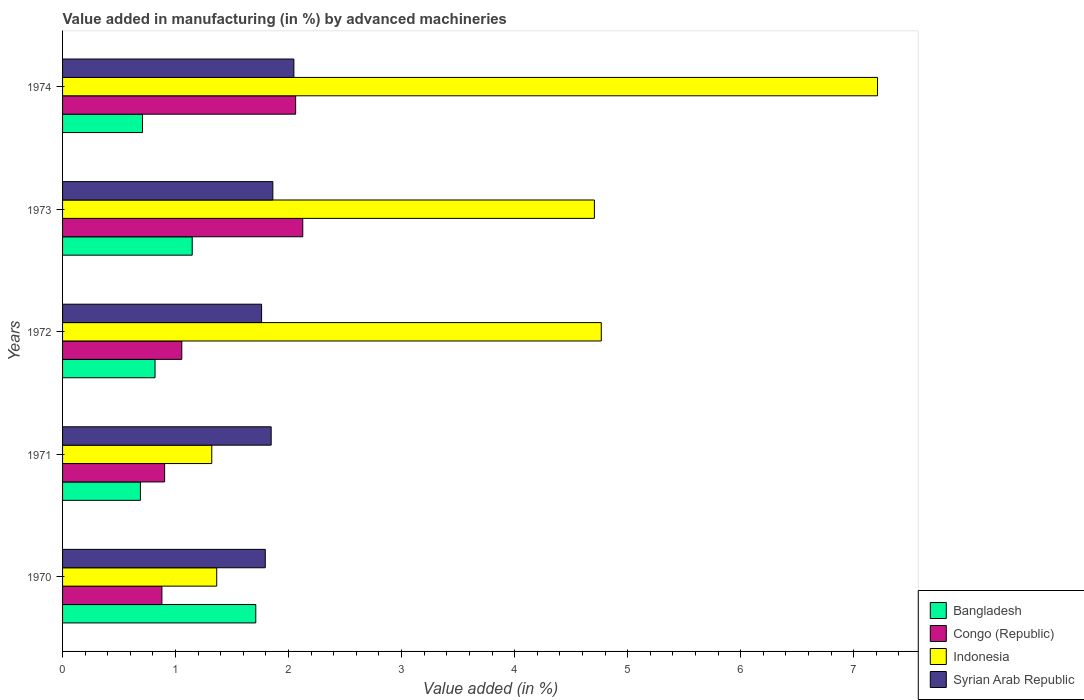How many groups of bars are there?
Give a very brief answer. 5. Are the number of bars on each tick of the Y-axis equal?
Keep it short and to the point. Yes. How many bars are there on the 2nd tick from the top?
Provide a succinct answer. 4. What is the percentage of value added in manufacturing by advanced machineries in Syrian Arab Republic in 1970?
Give a very brief answer. 1.79. Across all years, what is the maximum percentage of value added in manufacturing by advanced machineries in Congo (Republic)?
Provide a succinct answer. 2.13. Across all years, what is the minimum percentage of value added in manufacturing by advanced machineries in Congo (Republic)?
Provide a succinct answer. 0.88. In which year was the percentage of value added in manufacturing by advanced machineries in Indonesia maximum?
Provide a succinct answer. 1974. In which year was the percentage of value added in manufacturing by advanced machineries in Bangladesh minimum?
Provide a succinct answer. 1971. What is the total percentage of value added in manufacturing by advanced machineries in Syrian Arab Republic in the graph?
Give a very brief answer. 9.31. What is the difference between the percentage of value added in manufacturing by advanced machineries in Congo (Republic) in 1971 and that in 1973?
Your answer should be very brief. -1.22. What is the difference between the percentage of value added in manufacturing by advanced machineries in Indonesia in 1970 and the percentage of value added in manufacturing by advanced machineries in Bangladesh in 1973?
Give a very brief answer. 0.22. What is the average percentage of value added in manufacturing by advanced machineries in Indonesia per year?
Provide a short and direct response. 3.87. In the year 1972, what is the difference between the percentage of value added in manufacturing by advanced machineries in Bangladesh and percentage of value added in manufacturing by advanced machineries in Syrian Arab Republic?
Ensure brevity in your answer.  -0.94. What is the ratio of the percentage of value added in manufacturing by advanced machineries in Bangladesh in 1972 to that in 1973?
Provide a short and direct response. 0.71. Is the percentage of value added in manufacturing by advanced machineries in Indonesia in 1972 less than that in 1974?
Offer a terse response. Yes. Is the difference between the percentage of value added in manufacturing by advanced machineries in Bangladesh in 1971 and 1973 greater than the difference between the percentage of value added in manufacturing by advanced machineries in Syrian Arab Republic in 1971 and 1973?
Offer a very short reply. No. What is the difference between the highest and the second highest percentage of value added in manufacturing by advanced machineries in Indonesia?
Provide a short and direct response. 2.44. What is the difference between the highest and the lowest percentage of value added in manufacturing by advanced machineries in Congo (Republic)?
Your answer should be very brief. 1.25. Is the sum of the percentage of value added in manufacturing by advanced machineries in Syrian Arab Republic in 1972 and 1974 greater than the maximum percentage of value added in manufacturing by advanced machineries in Indonesia across all years?
Make the answer very short. No. Is it the case that in every year, the sum of the percentage of value added in manufacturing by advanced machineries in Syrian Arab Republic and percentage of value added in manufacturing by advanced machineries in Congo (Republic) is greater than the sum of percentage of value added in manufacturing by advanced machineries in Bangladesh and percentage of value added in manufacturing by advanced machineries in Indonesia?
Keep it short and to the point. No. What does the 4th bar from the top in 1973 represents?
Offer a very short reply. Bangladesh. What does the 2nd bar from the bottom in 1970 represents?
Your answer should be very brief. Congo (Republic). How many bars are there?
Ensure brevity in your answer.  20. Are all the bars in the graph horizontal?
Provide a succinct answer. Yes. Does the graph contain grids?
Keep it short and to the point. No. How many legend labels are there?
Your answer should be very brief. 4. What is the title of the graph?
Your answer should be compact. Value added in manufacturing (in %) by advanced machineries. What is the label or title of the X-axis?
Ensure brevity in your answer.  Value added (in %). What is the Value added (in %) of Bangladesh in 1970?
Ensure brevity in your answer.  1.71. What is the Value added (in %) of Congo (Republic) in 1970?
Make the answer very short. 0.88. What is the Value added (in %) of Indonesia in 1970?
Give a very brief answer. 1.36. What is the Value added (in %) in Syrian Arab Republic in 1970?
Offer a very short reply. 1.79. What is the Value added (in %) in Bangladesh in 1971?
Your response must be concise. 0.69. What is the Value added (in %) of Congo (Republic) in 1971?
Your answer should be compact. 0.9. What is the Value added (in %) in Indonesia in 1971?
Your response must be concise. 1.32. What is the Value added (in %) of Syrian Arab Republic in 1971?
Provide a succinct answer. 1.85. What is the Value added (in %) of Bangladesh in 1972?
Your answer should be very brief. 0.82. What is the Value added (in %) of Congo (Republic) in 1972?
Give a very brief answer. 1.06. What is the Value added (in %) in Indonesia in 1972?
Offer a terse response. 4.77. What is the Value added (in %) in Syrian Arab Republic in 1972?
Your answer should be compact. 1.76. What is the Value added (in %) in Bangladesh in 1973?
Make the answer very short. 1.15. What is the Value added (in %) of Congo (Republic) in 1973?
Keep it short and to the point. 2.13. What is the Value added (in %) of Indonesia in 1973?
Ensure brevity in your answer.  4.71. What is the Value added (in %) of Syrian Arab Republic in 1973?
Keep it short and to the point. 1.86. What is the Value added (in %) of Bangladesh in 1974?
Provide a succinct answer. 0.71. What is the Value added (in %) of Congo (Republic) in 1974?
Ensure brevity in your answer.  2.06. What is the Value added (in %) of Indonesia in 1974?
Ensure brevity in your answer.  7.21. What is the Value added (in %) of Syrian Arab Republic in 1974?
Offer a very short reply. 2.05. Across all years, what is the maximum Value added (in %) of Bangladesh?
Ensure brevity in your answer.  1.71. Across all years, what is the maximum Value added (in %) in Congo (Republic)?
Provide a succinct answer. 2.13. Across all years, what is the maximum Value added (in %) in Indonesia?
Offer a terse response. 7.21. Across all years, what is the maximum Value added (in %) in Syrian Arab Republic?
Make the answer very short. 2.05. Across all years, what is the minimum Value added (in %) of Bangladesh?
Your answer should be compact. 0.69. Across all years, what is the minimum Value added (in %) in Congo (Republic)?
Your answer should be very brief. 0.88. Across all years, what is the minimum Value added (in %) of Indonesia?
Offer a very short reply. 1.32. Across all years, what is the minimum Value added (in %) of Syrian Arab Republic?
Make the answer very short. 1.76. What is the total Value added (in %) of Bangladesh in the graph?
Provide a succinct answer. 5.07. What is the total Value added (in %) in Congo (Republic) in the graph?
Provide a succinct answer. 7.03. What is the total Value added (in %) in Indonesia in the graph?
Provide a succinct answer. 19.37. What is the total Value added (in %) in Syrian Arab Republic in the graph?
Provide a short and direct response. 9.31. What is the difference between the Value added (in %) in Bangladesh in 1970 and that in 1971?
Provide a short and direct response. 1.02. What is the difference between the Value added (in %) in Congo (Republic) in 1970 and that in 1971?
Give a very brief answer. -0.02. What is the difference between the Value added (in %) of Indonesia in 1970 and that in 1971?
Provide a succinct answer. 0.04. What is the difference between the Value added (in %) of Syrian Arab Republic in 1970 and that in 1971?
Offer a very short reply. -0.05. What is the difference between the Value added (in %) of Bangladesh in 1970 and that in 1972?
Your response must be concise. 0.89. What is the difference between the Value added (in %) in Congo (Republic) in 1970 and that in 1972?
Provide a succinct answer. -0.18. What is the difference between the Value added (in %) in Indonesia in 1970 and that in 1972?
Make the answer very short. -3.4. What is the difference between the Value added (in %) of Syrian Arab Republic in 1970 and that in 1972?
Provide a succinct answer. 0.03. What is the difference between the Value added (in %) of Bangladesh in 1970 and that in 1973?
Keep it short and to the point. 0.56. What is the difference between the Value added (in %) in Congo (Republic) in 1970 and that in 1973?
Offer a terse response. -1.25. What is the difference between the Value added (in %) of Indonesia in 1970 and that in 1973?
Provide a short and direct response. -3.34. What is the difference between the Value added (in %) of Syrian Arab Republic in 1970 and that in 1973?
Offer a very short reply. -0.07. What is the difference between the Value added (in %) of Bangladesh in 1970 and that in 1974?
Your answer should be compact. 1. What is the difference between the Value added (in %) of Congo (Republic) in 1970 and that in 1974?
Keep it short and to the point. -1.18. What is the difference between the Value added (in %) of Indonesia in 1970 and that in 1974?
Your response must be concise. -5.85. What is the difference between the Value added (in %) in Syrian Arab Republic in 1970 and that in 1974?
Make the answer very short. -0.25. What is the difference between the Value added (in %) of Bangladesh in 1971 and that in 1972?
Give a very brief answer. -0.13. What is the difference between the Value added (in %) of Congo (Republic) in 1971 and that in 1972?
Provide a short and direct response. -0.15. What is the difference between the Value added (in %) of Indonesia in 1971 and that in 1972?
Offer a terse response. -3.45. What is the difference between the Value added (in %) of Syrian Arab Republic in 1971 and that in 1972?
Make the answer very short. 0.08. What is the difference between the Value added (in %) in Bangladesh in 1971 and that in 1973?
Your answer should be very brief. -0.46. What is the difference between the Value added (in %) of Congo (Republic) in 1971 and that in 1973?
Your answer should be very brief. -1.22. What is the difference between the Value added (in %) in Indonesia in 1971 and that in 1973?
Your answer should be very brief. -3.39. What is the difference between the Value added (in %) in Syrian Arab Republic in 1971 and that in 1973?
Make the answer very short. -0.01. What is the difference between the Value added (in %) of Bangladesh in 1971 and that in 1974?
Provide a short and direct response. -0.02. What is the difference between the Value added (in %) in Congo (Republic) in 1971 and that in 1974?
Ensure brevity in your answer.  -1.16. What is the difference between the Value added (in %) of Indonesia in 1971 and that in 1974?
Your answer should be compact. -5.89. What is the difference between the Value added (in %) in Syrian Arab Republic in 1971 and that in 1974?
Your answer should be very brief. -0.2. What is the difference between the Value added (in %) of Bangladesh in 1972 and that in 1973?
Provide a succinct answer. -0.33. What is the difference between the Value added (in %) of Congo (Republic) in 1972 and that in 1973?
Your answer should be compact. -1.07. What is the difference between the Value added (in %) of Indonesia in 1972 and that in 1973?
Provide a short and direct response. 0.06. What is the difference between the Value added (in %) in Syrian Arab Republic in 1972 and that in 1973?
Your answer should be compact. -0.1. What is the difference between the Value added (in %) in Bangladesh in 1972 and that in 1974?
Your response must be concise. 0.11. What is the difference between the Value added (in %) in Congo (Republic) in 1972 and that in 1974?
Keep it short and to the point. -1.01. What is the difference between the Value added (in %) in Indonesia in 1972 and that in 1974?
Make the answer very short. -2.44. What is the difference between the Value added (in %) of Syrian Arab Republic in 1972 and that in 1974?
Provide a succinct answer. -0.29. What is the difference between the Value added (in %) in Bangladesh in 1973 and that in 1974?
Offer a terse response. 0.44. What is the difference between the Value added (in %) of Congo (Republic) in 1973 and that in 1974?
Keep it short and to the point. 0.06. What is the difference between the Value added (in %) of Indonesia in 1973 and that in 1974?
Offer a terse response. -2.51. What is the difference between the Value added (in %) of Syrian Arab Republic in 1973 and that in 1974?
Offer a terse response. -0.19. What is the difference between the Value added (in %) in Bangladesh in 1970 and the Value added (in %) in Congo (Republic) in 1971?
Give a very brief answer. 0.81. What is the difference between the Value added (in %) in Bangladesh in 1970 and the Value added (in %) in Indonesia in 1971?
Offer a very short reply. 0.39. What is the difference between the Value added (in %) of Bangladesh in 1970 and the Value added (in %) of Syrian Arab Republic in 1971?
Offer a very short reply. -0.14. What is the difference between the Value added (in %) in Congo (Republic) in 1970 and the Value added (in %) in Indonesia in 1971?
Provide a succinct answer. -0.44. What is the difference between the Value added (in %) of Congo (Republic) in 1970 and the Value added (in %) of Syrian Arab Republic in 1971?
Your answer should be compact. -0.97. What is the difference between the Value added (in %) of Indonesia in 1970 and the Value added (in %) of Syrian Arab Republic in 1971?
Make the answer very short. -0.48. What is the difference between the Value added (in %) of Bangladesh in 1970 and the Value added (in %) of Congo (Republic) in 1972?
Give a very brief answer. 0.65. What is the difference between the Value added (in %) in Bangladesh in 1970 and the Value added (in %) in Indonesia in 1972?
Ensure brevity in your answer.  -3.06. What is the difference between the Value added (in %) in Bangladesh in 1970 and the Value added (in %) in Syrian Arab Republic in 1972?
Offer a very short reply. -0.05. What is the difference between the Value added (in %) in Congo (Republic) in 1970 and the Value added (in %) in Indonesia in 1972?
Keep it short and to the point. -3.89. What is the difference between the Value added (in %) in Congo (Republic) in 1970 and the Value added (in %) in Syrian Arab Republic in 1972?
Your response must be concise. -0.88. What is the difference between the Value added (in %) of Indonesia in 1970 and the Value added (in %) of Syrian Arab Republic in 1972?
Provide a short and direct response. -0.4. What is the difference between the Value added (in %) in Bangladesh in 1970 and the Value added (in %) in Congo (Republic) in 1973?
Offer a very short reply. -0.42. What is the difference between the Value added (in %) in Bangladesh in 1970 and the Value added (in %) in Indonesia in 1973?
Ensure brevity in your answer.  -3. What is the difference between the Value added (in %) of Bangladesh in 1970 and the Value added (in %) of Syrian Arab Republic in 1973?
Your answer should be compact. -0.15. What is the difference between the Value added (in %) of Congo (Republic) in 1970 and the Value added (in %) of Indonesia in 1973?
Give a very brief answer. -3.83. What is the difference between the Value added (in %) of Congo (Republic) in 1970 and the Value added (in %) of Syrian Arab Republic in 1973?
Offer a terse response. -0.98. What is the difference between the Value added (in %) of Indonesia in 1970 and the Value added (in %) of Syrian Arab Republic in 1973?
Your answer should be very brief. -0.5. What is the difference between the Value added (in %) of Bangladesh in 1970 and the Value added (in %) of Congo (Republic) in 1974?
Give a very brief answer. -0.35. What is the difference between the Value added (in %) in Bangladesh in 1970 and the Value added (in %) in Indonesia in 1974?
Your answer should be compact. -5.5. What is the difference between the Value added (in %) of Bangladesh in 1970 and the Value added (in %) of Syrian Arab Republic in 1974?
Offer a very short reply. -0.34. What is the difference between the Value added (in %) of Congo (Republic) in 1970 and the Value added (in %) of Indonesia in 1974?
Provide a short and direct response. -6.33. What is the difference between the Value added (in %) in Congo (Republic) in 1970 and the Value added (in %) in Syrian Arab Republic in 1974?
Your response must be concise. -1.17. What is the difference between the Value added (in %) of Indonesia in 1970 and the Value added (in %) of Syrian Arab Republic in 1974?
Provide a succinct answer. -0.68. What is the difference between the Value added (in %) in Bangladesh in 1971 and the Value added (in %) in Congo (Republic) in 1972?
Your answer should be very brief. -0.37. What is the difference between the Value added (in %) of Bangladesh in 1971 and the Value added (in %) of Indonesia in 1972?
Your response must be concise. -4.08. What is the difference between the Value added (in %) of Bangladesh in 1971 and the Value added (in %) of Syrian Arab Republic in 1972?
Ensure brevity in your answer.  -1.07. What is the difference between the Value added (in %) in Congo (Republic) in 1971 and the Value added (in %) in Indonesia in 1972?
Provide a succinct answer. -3.86. What is the difference between the Value added (in %) in Congo (Republic) in 1971 and the Value added (in %) in Syrian Arab Republic in 1972?
Give a very brief answer. -0.86. What is the difference between the Value added (in %) of Indonesia in 1971 and the Value added (in %) of Syrian Arab Republic in 1972?
Your answer should be compact. -0.44. What is the difference between the Value added (in %) of Bangladesh in 1971 and the Value added (in %) of Congo (Republic) in 1973?
Give a very brief answer. -1.44. What is the difference between the Value added (in %) of Bangladesh in 1971 and the Value added (in %) of Indonesia in 1973?
Provide a succinct answer. -4.02. What is the difference between the Value added (in %) of Bangladesh in 1971 and the Value added (in %) of Syrian Arab Republic in 1973?
Make the answer very short. -1.17. What is the difference between the Value added (in %) of Congo (Republic) in 1971 and the Value added (in %) of Indonesia in 1973?
Give a very brief answer. -3.8. What is the difference between the Value added (in %) of Congo (Republic) in 1971 and the Value added (in %) of Syrian Arab Republic in 1973?
Give a very brief answer. -0.96. What is the difference between the Value added (in %) of Indonesia in 1971 and the Value added (in %) of Syrian Arab Republic in 1973?
Keep it short and to the point. -0.54. What is the difference between the Value added (in %) of Bangladesh in 1971 and the Value added (in %) of Congo (Republic) in 1974?
Your answer should be very brief. -1.37. What is the difference between the Value added (in %) of Bangladesh in 1971 and the Value added (in %) of Indonesia in 1974?
Give a very brief answer. -6.52. What is the difference between the Value added (in %) of Bangladesh in 1971 and the Value added (in %) of Syrian Arab Republic in 1974?
Your response must be concise. -1.36. What is the difference between the Value added (in %) in Congo (Republic) in 1971 and the Value added (in %) in Indonesia in 1974?
Your answer should be very brief. -6.31. What is the difference between the Value added (in %) in Congo (Republic) in 1971 and the Value added (in %) in Syrian Arab Republic in 1974?
Your answer should be very brief. -1.14. What is the difference between the Value added (in %) in Indonesia in 1971 and the Value added (in %) in Syrian Arab Republic in 1974?
Your answer should be very brief. -0.73. What is the difference between the Value added (in %) of Bangladesh in 1972 and the Value added (in %) of Congo (Republic) in 1973?
Your answer should be very brief. -1.31. What is the difference between the Value added (in %) in Bangladesh in 1972 and the Value added (in %) in Indonesia in 1973?
Make the answer very short. -3.89. What is the difference between the Value added (in %) of Bangladesh in 1972 and the Value added (in %) of Syrian Arab Republic in 1973?
Your answer should be compact. -1.04. What is the difference between the Value added (in %) of Congo (Republic) in 1972 and the Value added (in %) of Indonesia in 1973?
Offer a terse response. -3.65. What is the difference between the Value added (in %) of Congo (Republic) in 1972 and the Value added (in %) of Syrian Arab Republic in 1973?
Offer a very short reply. -0.81. What is the difference between the Value added (in %) of Indonesia in 1972 and the Value added (in %) of Syrian Arab Republic in 1973?
Provide a succinct answer. 2.91. What is the difference between the Value added (in %) of Bangladesh in 1972 and the Value added (in %) of Congo (Republic) in 1974?
Your answer should be very brief. -1.24. What is the difference between the Value added (in %) of Bangladesh in 1972 and the Value added (in %) of Indonesia in 1974?
Your answer should be very brief. -6.39. What is the difference between the Value added (in %) in Bangladesh in 1972 and the Value added (in %) in Syrian Arab Republic in 1974?
Your response must be concise. -1.23. What is the difference between the Value added (in %) of Congo (Republic) in 1972 and the Value added (in %) of Indonesia in 1974?
Provide a short and direct response. -6.16. What is the difference between the Value added (in %) of Congo (Republic) in 1972 and the Value added (in %) of Syrian Arab Republic in 1974?
Your answer should be compact. -0.99. What is the difference between the Value added (in %) of Indonesia in 1972 and the Value added (in %) of Syrian Arab Republic in 1974?
Offer a terse response. 2.72. What is the difference between the Value added (in %) of Bangladesh in 1973 and the Value added (in %) of Congo (Republic) in 1974?
Ensure brevity in your answer.  -0.92. What is the difference between the Value added (in %) in Bangladesh in 1973 and the Value added (in %) in Indonesia in 1974?
Offer a terse response. -6.06. What is the difference between the Value added (in %) in Bangladesh in 1973 and the Value added (in %) in Syrian Arab Republic in 1974?
Give a very brief answer. -0.9. What is the difference between the Value added (in %) of Congo (Republic) in 1973 and the Value added (in %) of Indonesia in 1974?
Keep it short and to the point. -5.09. What is the difference between the Value added (in %) of Congo (Republic) in 1973 and the Value added (in %) of Syrian Arab Republic in 1974?
Keep it short and to the point. 0.08. What is the difference between the Value added (in %) in Indonesia in 1973 and the Value added (in %) in Syrian Arab Republic in 1974?
Make the answer very short. 2.66. What is the average Value added (in %) in Bangladesh per year?
Your response must be concise. 1.01. What is the average Value added (in %) in Congo (Republic) per year?
Provide a short and direct response. 1.41. What is the average Value added (in %) in Indonesia per year?
Offer a terse response. 3.87. What is the average Value added (in %) in Syrian Arab Republic per year?
Provide a succinct answer. 1.86. In the year 1970, what is the difference between the Value added (in %) in Bangladesh and Value added (in %) in Congo (Republic)?
Make the answer very short. 0.83. In the year 1970, what is the difference between the Value added (in %) in Bangladesh and Value added (in %) in Indonesia?
Make the answer very short. 0.35. In the year 1970, what is the difference between the Value added (in %) in Bangladesh and Value added (in %) in Syrian Arab Republic?
Give a very brief answer. -0.08. In the year 1970, what is the difference between the Value added (in %) in Congo (Republic) and Value added (in %) in Indonesia?
Offer a terse response. -0.48. In the year 1970, what is the difference between the Value added (in %) in Congo (Republic) and Value added (in %) in Syrian Arab Republic?
Offer a very short reply. -0.91. In the year 1970, what is the difference between the Value added (in %) in Indonesia and Value added (in %) in Syrian Arab Republic?
Offer a very short reply. -0.43. In the year 1971, what is the difference between the Value added (in %) in Bangladesh and Value added (in %) in Congo (Republic)?
Make the answer very short. -0.21. In the year 1971, what is the difference between the Value added (in %) of Bangladesh and Value added (in %) of Indonesia?
Your answer should be very brief. -0.63. In the year 1971, what is the difference between the Value added (in %) of Bangladesh and Value added (in %) of Syrian Arab Republic?
Offer a very short reply. -1.16. In the year 1971, what is the difference between the Value added (in %) of Congo (Republic) and Value added (in %) of Indonesia?
Provide a short and direct response. -0.42. In the year 1971, what is the difference between the Value added (in %) in Congo (Republic) and Value added (in %) in Syrian Arab Republic?
Ensure brevity in your answer.  -0.94. In the year 1971, what is the difference between the Value added (in %) of Indonesia and Value added (in %) of Syrian Arab Republic?
Offer a very short reply. -0.53. In the year 1972, what is the difference between the Value added (in %) of Bangladesh and Value added (in %) of Congo (Republic)?
Your answer should be very brief. -0.24. In the year 1972, what is the difference between the Value added (in %) of Bangladesh and Value added (in %) of Indonesia?
Your answer should be very brief. -3.95. In the year 1972, what is the difference between the Value added (in %) in Bangladesh and Value added (in %) in Syrian Arab Republic?
Ensure brevity in your answer.  -0.94. In the year 1972, what is the difference between the Value added (in %) in Congo (Republic) and Value added (in %) in Indonesia?
Your response must be concise. -3.71. In the year 1972, what is the difference between the Value added (in %) of Congo (Republic) and Value added (in %) of Syrian Arab Republic?
Make the answer very short. -0.71. In the year 1972, what is the difference between the Value added (in %) in Indonesia and Value added (in %) in Syrian Arab Republic?
Give a very brief answer. 3.01. In the year 1973, what is the difference between the Value added (in %) in Bangladesh and Value added (in %) in Congo (Republic)?
Ensure brevity in your answer.  -0.98. In the year 1973, what is the difference between the Value added (in %) of Bangladesh and Value added (in %) of Indonesia?
Your answer should be compact. -3.56. In the year 1973, what is the difference between the Value added (in %) of Bangladesh and Value added (in %) of Syrian Arab Republic?
Your answer should be very brief. -0.71. In the year 1973, what is the difference between the Value added (in %) of Congo (Republic) and Value added (in %) of Indonesia?
Ensure brevity in your answer.  -2.58. In the year 1973, what is the difference between the Value added (in %) in Congo (Republic) and Value added (in %) in Syrian Arab Republic?
Keep it short and to the point. 0.26. In the year 1973, what is the difference between the Value added (in %) of Indonesia and Value added (in %) of Syrian Arab Republic?
Your response must be concise. 2.85. In the year 1974, what is the difference between the Value added (in %) in Bangladesh and Value added (in %) in Congo (Republic)?
Provide a succinct answer. -1.35. In the year 1974, what is the difference between the Value added (in %) in Bangladesh and Value added (in %) in Indonesia?
Provide a short and direct response. -6.5. In the year 1974, what is the difference between the Value added (in %) in Bangladesh and Value added (in %) in Syrian Arab Republic?
Ensure brevity in your answer.  -1.34. In the year 1974, what is the difference between the Value added (in %) in Congo (Republic) and Value added (in %) in Indonesia?
Provide a succinct answer. -5.15. In the year 1974, what is the difference between the Value added (in %) of Congo (Republic) and Value added (in %) of Syrian Arab Republic?
Give a very brief answer. 0.02. In the year 1974, what is the difference between the Value added (in %) in Indonesia and Value added (in %) in Syrian Arab Republic?
Offer a very short reply. 5.16. What is the ratio of the Value added (in %) of Bangladesh in 1970 to that in 1971?
Keep it short and to the point. 2.48. What is the ratio of the Value added (in %) in Congo (Republic) in 1970 to that in 1971?
Ensure brevity in your answer.  0.97. What is the ratio of the Value added (in %) in Indonesia in 1970 to that in 1971?
Give a very brief answer. 1.03. What is the ratio of the Value added (in %) in Syrian Arab Republic in 1970 to that in 1971?
Offer a very short reply. 0.97. What is the ratio of the Value added (in %) of Bangladesh in 1970 to that in 1972?
Your response must be concise. 2.09. What is the ratio of the Value added (in %) of Congo (Republic) in 1970 to that in 1972?
Offer a very short reply. 0.83. What is the ratio of the Value added (in %) in Indonesia in 1970 to that in 1972?
Offer a terse response. 0.29. What is the ratio of the Value added (in %) in Syrian Arab Republic in 1970 to that in 1972?
Give a very brief answer. 1.02. What is the ratio of the Value added (in %) in Bangladesh in 1970 to that in 1973?
Your answer should be compact. 1.49. What is the ratio of the Value added (in %) of Congo (Republic) in 1970 to that in 1973?
Your answer should be compact. 0.41. What is the ratio of the Value added (in %) in Indonesia in 1970 to that in 1973?
Keep it short and to the point. 0.29. What is the ratio of the Value added (in %) in Syrian Arab Republic in 1970 to that in 1973?
Your response must be concise. 0.96. What is the ratio of the Value added (in %) of Bangladesh in 1970 to that in 1974?
Ensure brevity in your answer.  2.42. What is the ratio of the Value added (in %) in Congo (Republic) in 1970 to that in 1974?
Ensure brevity in your answer.  0.43. What is the ratio of the Value added (in %) in Indonesia in 1970 to that in 1974?
Offer a terse response. 0.19. What is the ratio of the Value added (in %) in Syrian Arab Republic in 1970 to that in 1974?
Keep it short and to the point. 0.88. What is the ratio of the Value added (in %) in Bangladesh in 1971 to that in 1972?
Your answer should be very brief. 0.84. What is the ratio of the Value added (in %) in Congo (Republic) in 1971 to that in 1972?
Keep it short and to the point. 0.86. What is the ratio of the Value added (in %) of Indonesia in 1971 to that in 1972?
Offer a very short reply. 0.28. What is the ratio of the Value added (in %) in Syrian Arab Republic in 1971 to that in 1972?
Offer a very short reply. 1.05. What is the ratio of the Value added (in %) of Bangladesh in 1971 to that in 1973?
Offer a very short reply. 0.6. What is the ratio of the Value added (in %) in Congo (Republic) in 1971 to that in 1973?
Your answer should be very brief. 0.42. What is the ratio of the Value added (in %) of Indonesia in 1971 to that in 1973?
Your answer should be very brief. 0.28. What is the ratio of the Value added (in %) in Bangladesh in 1971 to that in 1974?
Provide a short and direct response. 0.97. What is the ratio of the Value added (in %) in Congo (Republic) in 1971 to that in 1974?
Your response must be concise. 0.44. What is the ratio of the Value added (in %) in Indonesia in 1971 to that in 1974?
Ensure brevity in your answer.  0.18. What is the ratio of the Value added (in %) of Syrian Arab Republic in 1971 to that in 1974?
Ensure brevity in your answer.  0.9. What is the ratio of the Value added (in %) of Bangladesh in 1972 to that in 1973?
Provide a short and direct response. 0.71. What is the ratio of the Value added (in %) in Congo (Republic) in 1972 to that in 1973?
Keep it short and to the point. 0.5. What is the ratio of the Value added (in %) of Indonesia in 1972 to that in 1973?
Your answer should be compact. 1.01. What is the ratio of the Value added (in %) of Syrian Arab Republic in 1972 to that in 1973?
Your response must be concise. 0.95. What is the ratio of the Value added (in %) of Bangladesh in 1972 to that in 1974?
Give a very brief answer. 1.16. What is the ratio of the Value added (in %) in Congo (Republic) in 1972 to that in 1974?
Offer a very short reply. 0.51. What is the ratio of the Value added (in %) in Indonesia in 1972 to that in 1974?
Keep it short and to the point. 0.66. What is the ratio of the Value added (in %) in Syrian Arab Republic in 1972 to that in 1974?
Ensure brevity in your answer.  0.86. What is the ratio of the Value added (in %) in Bangladesh in 1973 to that in 1974?
Offer a very short reply. 1.62. What is the ratio of the Value added (in %) of Congo (Republic) in 1973 to that in 1974?
Provide a succinct answer. 1.03. What is the ratio of the Value added (in %) in Indonesia in 1973 to that in 1974?
Ensure brevity in your answer.  0.65. What is the ratio of the Value added (in %) of Syrian Arab Republic in 1973 to that in 1974?
Keep it short and to the point. 0.91. What is the difference between the highest and the second highest Value added (in %) in Bangladesh?
Offer a very short reply. 0.56. What is the difference between the highest and the second highest Value added (in %) of Congo (Republic)?
Your response must be concise. 0.06. What is the difference between the highest and the second highest Value added (in %) of Indonesia?
Your response must be concise. 2.44. What is the difference between the highest and the second highest Value added (in %) in Syrian Arab Republic?
Provide a succinct answer. 0.19. What is the difference between the highest and the lowest Value added (in %) in Bangladesh?
Provide a succinct answer. 1.02. What is the difference between the highest and the lowest Value added (in %) in Congo (Republic)?
Make the answer very short. 1.25. What is the difference between the highest and the lowest Value added (in %) of Indonesia?
Give a very brief answer. 5.89. What is the difference between the highest and the lowest Value added (in %) in Syrian Arab Republic?
Your answer should be very brief. 0.29. 